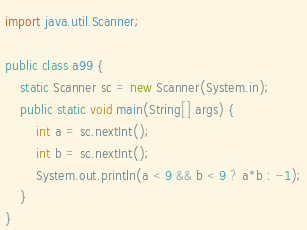<code> <loc_0><loc_0><loc_500><loc_500><_Java_>import java.util.Scanner;

public class a99 {
    static Scanner sc = new Scanner(System.in);
    public static void main(String[] args) {
        int a = sc.nextInt();
        int b = sc.nextInt();
        System.out.println(a < 9 && b < 9 ? a*b : -1);
    }
}</code> 